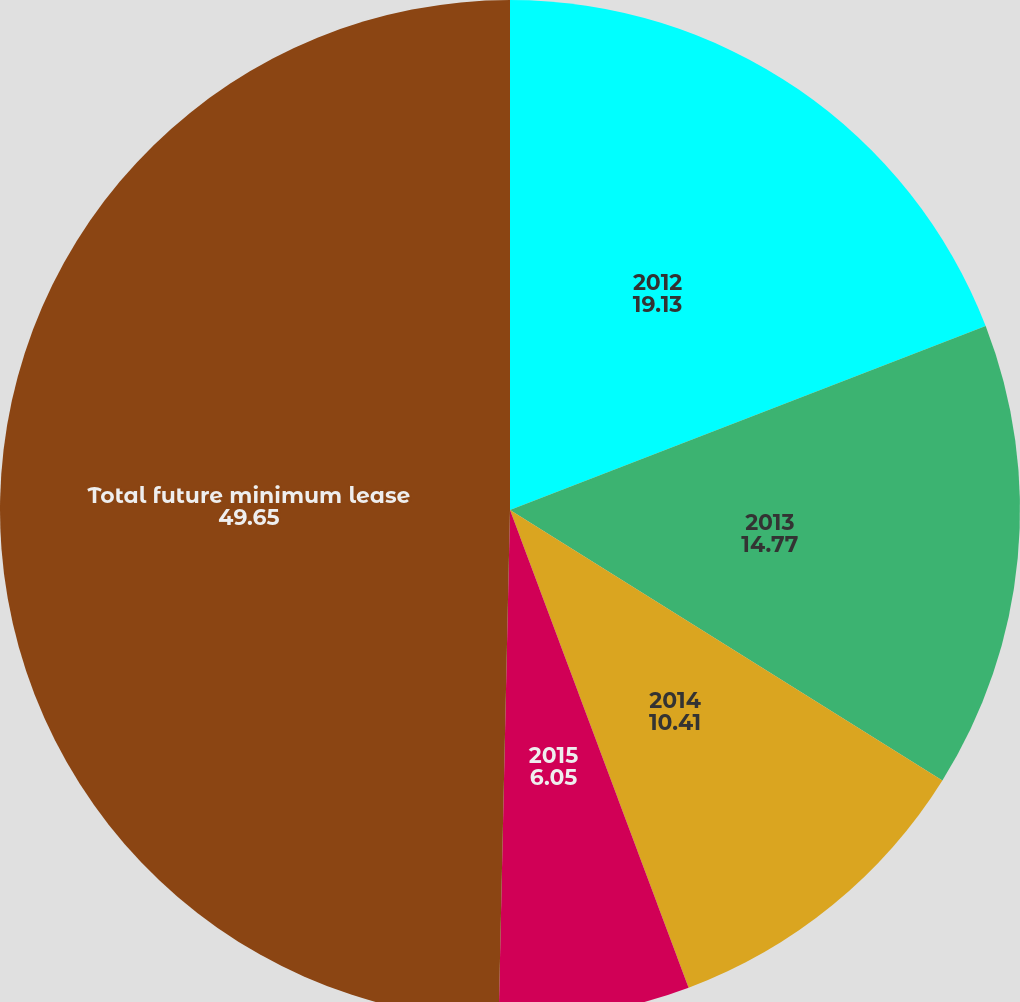<chart> <loc_0><loc_0><loc_500><loc_500><pie_chart><fcel>2012<fcel>2013<fcel>2014<fcel>2015<fcel>Total future minimum lease<nl><fcel>19.13%<fcel>14.77%<fcel>10.41%<fcel>6.05%<fcel>49.65%<nl></chart> 